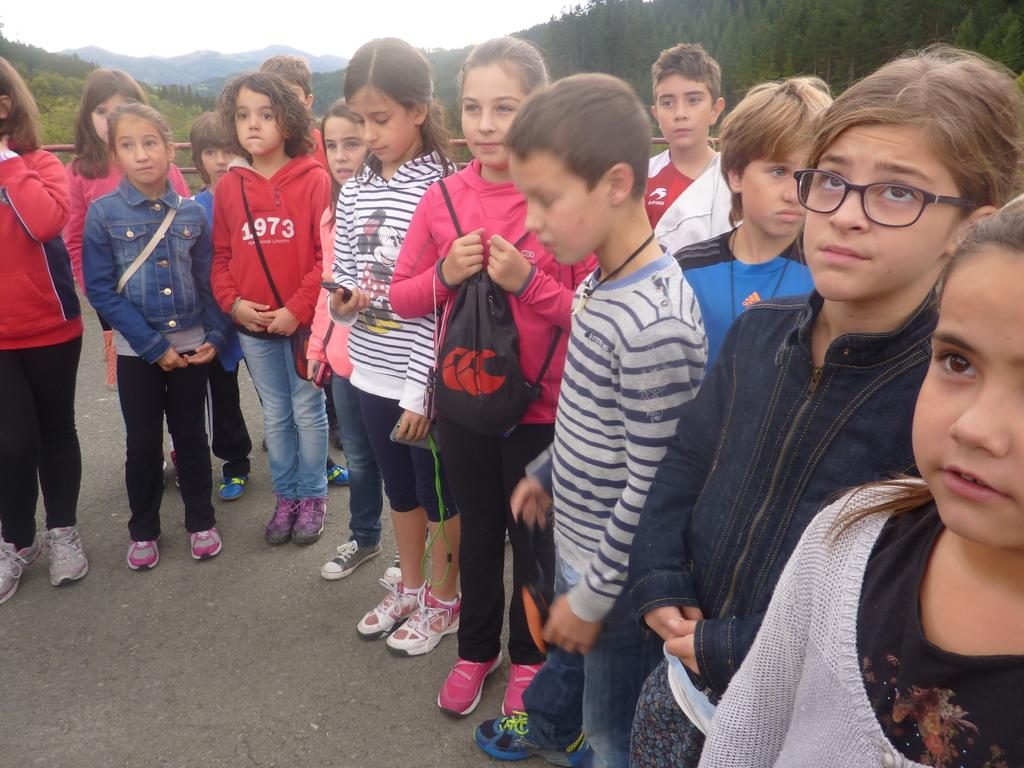What are the kids doing in the image? The kids are standing on the path in the image. What can be seen in the background of the image? There are rods, plants, trees, and mountains in the background of the image. What type of lock is holding the kids on the path in the image? There is no lock present in the image; the kids are standing freely on the path. 